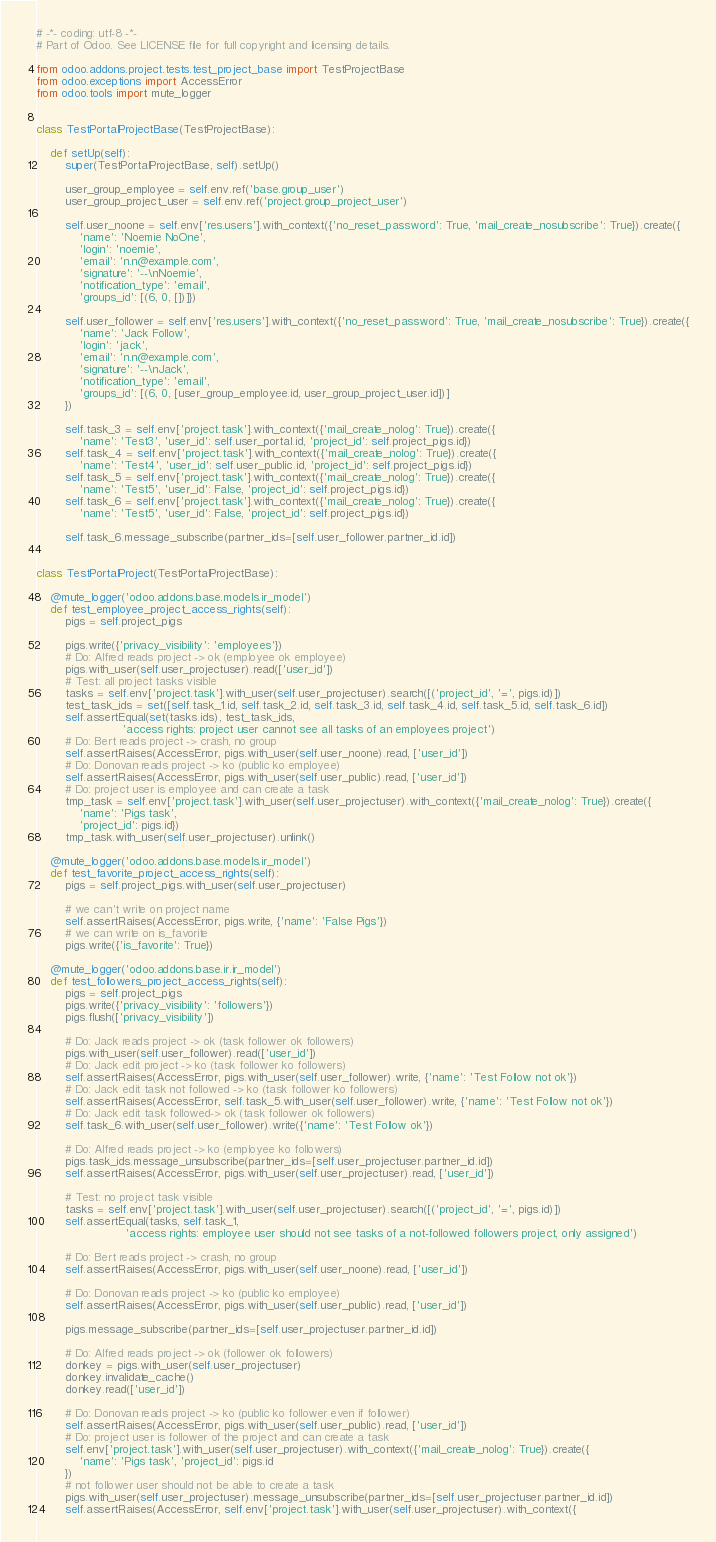Convert code to text. <code><loc_0><loc_0><loc_500><loc_500><_Python_># -*- coding: utf-8 -*-
# Part of Odoo. See LICENSE file for full copyright and licensing details.

from odoo.addons.project.tests.test_project_base import TestProjectBase
from odoo.exceptions import AccessError
from odoo.tools import mute_logger


class TestPortalProjectBase(TestProjectBase):

    def setUp(self):
        super(TestPortalProjectBase, self).setUp()

        user_group_employee = self.env.ref('base.group_user')
        user_group_project_user = self.env.ref('project.group_project_user')

        self.user_noone = self.env['res.users'].with_context({'no_reset_password': True, 'mail_create_nosubscribe': True}).create({
            'name': 'Noemie NoOne',
            'login': 'noemie',
            'email': 'n.n@example.com',
            'signature': '--\nNoemie',
            'notification_type': 'email',
            'groups_id': [(6, 0, [])]})

        self.user_follower = self.env['res.users'].with_context({'no_reset_password': True, 'mail_create_nosubscribe': True}).create({
            'name': 'Jack Follow',
            'login': 'jack',
            'email': 'n.n@example.com',
            'signature': '--\nJack',
            'notification_type': 'email',
            'groups_id': [(6, 0, [user_group_employee.id, user_group_project_user.id])]
        })

        self.task_3 = self.env['project.task'].with_context({'mail_create_nolog': True}).create({
            'name': 'Test3', 'user_id': self.user_portal.id, 'project_id': self.project_pigs.id})
        self.task_4 = self.env['project.task'].with_context({'mail_create_nolog': True}).create({
            'name': 'Test4', 'user_id': self.user_public.id, 'project_id': self.project_pigs.id})
        self.task_5 = self.env['project.task'].with_context({'mail_create_nolog': True}).create({
            'name': 'Test5', 'user_id': False, 'project_id': self.project_pigs.id})
        self.task_6 = self.env['project.task'].with_context({'mail_create_nolog': True}).create({
            'name': 'Test5', 'user_id': False, 'project_id': self.project_pigs.id})

        self.task_6.message_subscribe(partner_ids=[self.user_follower.partner_id.id])


class TestPortalProject(TestPortalProjectBase):

    @mute_logger('odoo.addons.base.models.ir_model')
    def test_employee_project_access_rights(self):
        pigs = self.project_pigs

        pigs.write({'privacy_visibility': 'employees'})
        # Do: Alfred reads project -> ok (employee ok employee)
        pigs.with_user(self.user_projectuser).read(['user_id'])
        # Test: all project tasks visible
        tasks = self.env['project.task'].with_user(self.user_projectuser).search([('project_id', '=', pigs.id)])
        test_task_ids = set([self.task_1.id, self.task_2.id, self.task_3.id, self.task_4.id, self.task_5.id, self.task_6.id])
        self.assertEqual(set(tasks.ids), test_task_ids,
                        'access rights: project user cannot see all tasks of an employees project')
        # Do: Bert reads project -> crash, no group
        self.assertRaises(AccessError, pigs.with_user(self.user_noone).read, ['user_id'])
        # Do: Donovan reads project -> ko (public ko employee)
        self.assertRaises(AccessError, pigs.with_user(self.user_public).read, ['user_id'])
        # Do: project user is employee and can create a task
        tmp_task = self.env['project.task'].with_user(self.user_projectuser).with_context({'mail_create_nolog': True}).create({
            'name': 'Pigs task',
            'project_id': pigs.id})
        tmp_task.with_user(self.user_projectuser).unlink()

    @mute_logger('odoo.addons.base.models.ir_model')
    def test_favorite_project_access_rights(self):
        pigs = self.project_pigs.with_user(self.user_projectuser)

        # we can't write on project name
        self.assertRaises(AccessError, pigs.write, {'name': 'False Pigs'})
        # we can write on is_favorite
        pigs.write({'is_favorite': True})

    @mute_logger('odoo.addons.base.ir.ir_model')
    def test_followers_project_access_rights(self):
        pigs = self.project_pigs
        pigs.write({'privacy_visibility': 'followers'})
        pigs.flush(['privacy_visibility'])

        # Do: Jack reads project -> ok (task follower ok followers)
        pigs.with_user(self.user_follower).read(['user_id'])
        # Do: Jack edit project -> ko (task follower ko followers)
        self.assertRaises(AccessError, pigs.with_user(self.user_follower).write, {'name': 'Test Follow not ok'})
        # Do: Jack edit task not followed -> ko (task follower ko followers)
        self.assertRaises(AccessError, self.task_5.with_user(self.user_follower).write, {'name': 'Test Follow not ok'})
        # Do: Jack edit task followed-> ok (task follower ok followers)
        self.task_6.with_user(self.user_follower).write({'name': 'Test Follow ok'})

        # Do: Alfred reads project -> ko (employee ko followers)
        pigs.task_ids.message_unsubscribe(partner_ids=[self.user_projectuser.partner_id.id])
        self.assertRaises(AccessError, pigs.with_user(self.user_projectuser).read, ['user_id'])

        # Test: no project task visible
        tasks = self.env['project.task'].with_user(self.user_projectuser).search([('project_id', '=', pigs.id)])
        self.assertEqual(tasks, self.task_1,
                         'access rights: employee user should not see tasks of a not-followed followers project, only assigned')

        # Do: Bert reads project -> crash, no group
        self.assertRaises(AccessError, pigs.with_user(self.user_noone).read, ['user_id'])

        # Do: Donovan reads project -> ko (public ko employee)
        self.assertRaises(AccessError, pigs.with_user(self.user_public).read, ['user_id'])

        pigs.message_subscribe(partner_ids=[self.user_projectuser.partner_id.id])

        # Do: Alfred reads project -> ok (follower ok followers)
        donkey = pigs.with_user(self.user_projectuser)
        donkey.invalidate_cache()
        donkey.read(['user_id'])

        # Do: Donovan reads project -> ko (public ko follower even if follower)
        self.assertRaises(AccessError, pigs.with_user(self.user_public).read, ['user_id'])
        # Do: project user is follower of the project and can create a task
        self.env['project.task'].with_user(self.user_projectuser).with_context({'mail_create_nolog': True}).create({
            'name': 'Pigs task', 'project_id': pigs.id
        })
        # not follower user should not be able to create a task
        pigs.with_user(self.user_projectuser).message_unsubscribe(partner_ids=[self.user_projectuser.partner_id.id])
        self.assertRaises(AccessError, self.env['project.task'].with_user(self.user_projectuser).with_context({</code> 